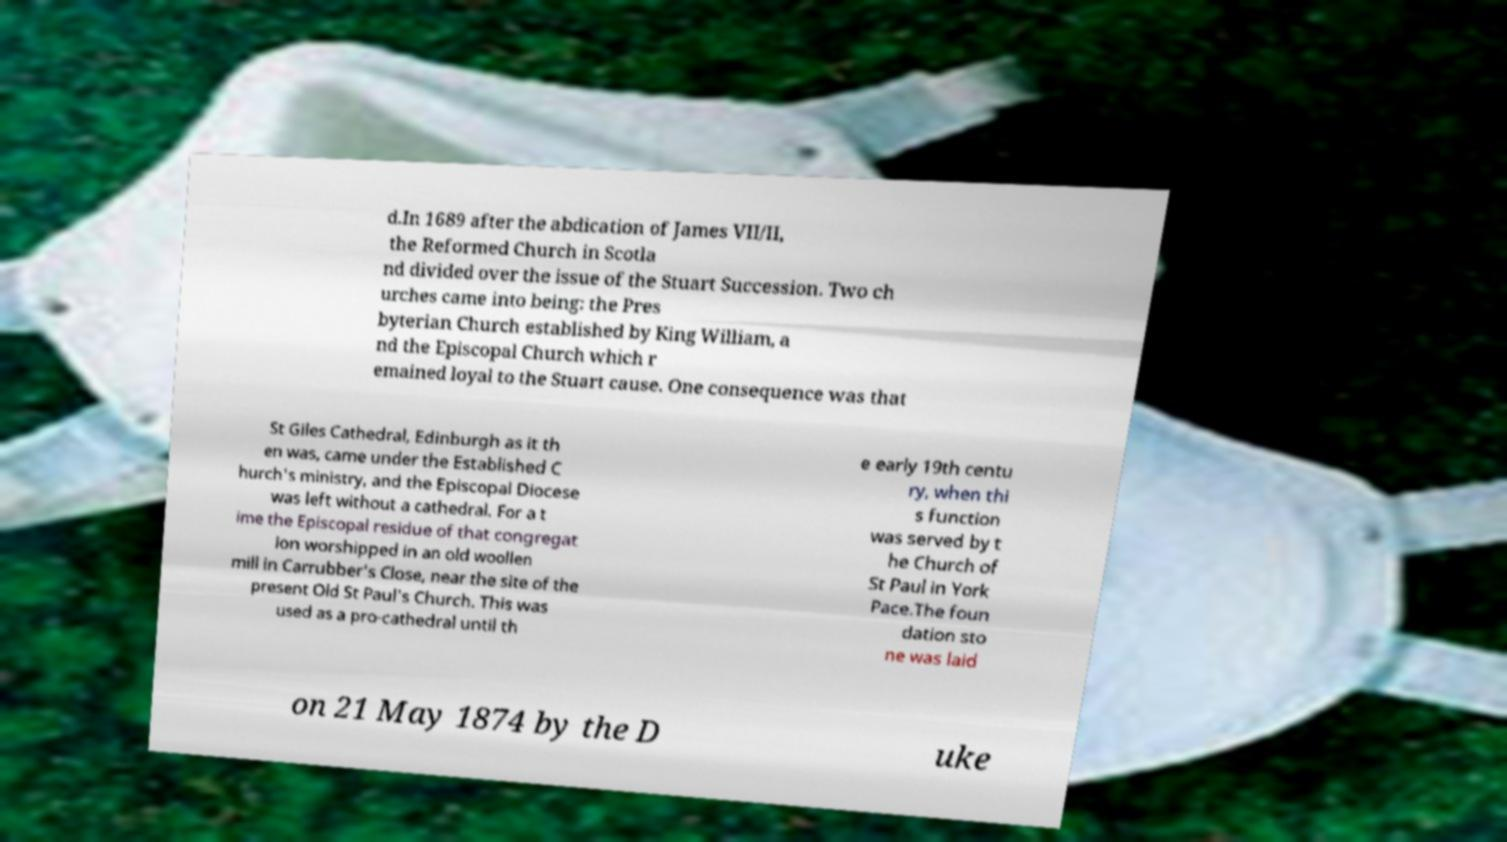What messages or text are displayed in this image? I need them in a readable, typed format. d.In 1689 after the abdication of James VII/II, the Reformed Church in Scotla nd divided over the issue of the Stuart Succession. Two ch urches came into being: the Pres byterian Church established by King William, a nd the Episcopal Church which r emained loyal to the Stuart cause. One consequence was that St Giles Cathedral, Edinburgh as it th en was, came under the Established C hurch's ministry, and the Episcopal Diocese was left without a cathedral. For a t ime the Episcopal residue of that congregat ion worshipped in an old woollen mill in Carrubber's Close, near the site of the present Old St Paul's Church. This was used as a pro-cathedral until th e early 19th centu ry, when thi s function was served by t he Church of St Paul in York Pace.The foun dation sto ne was laid on 21 May 1874 by the D uke 